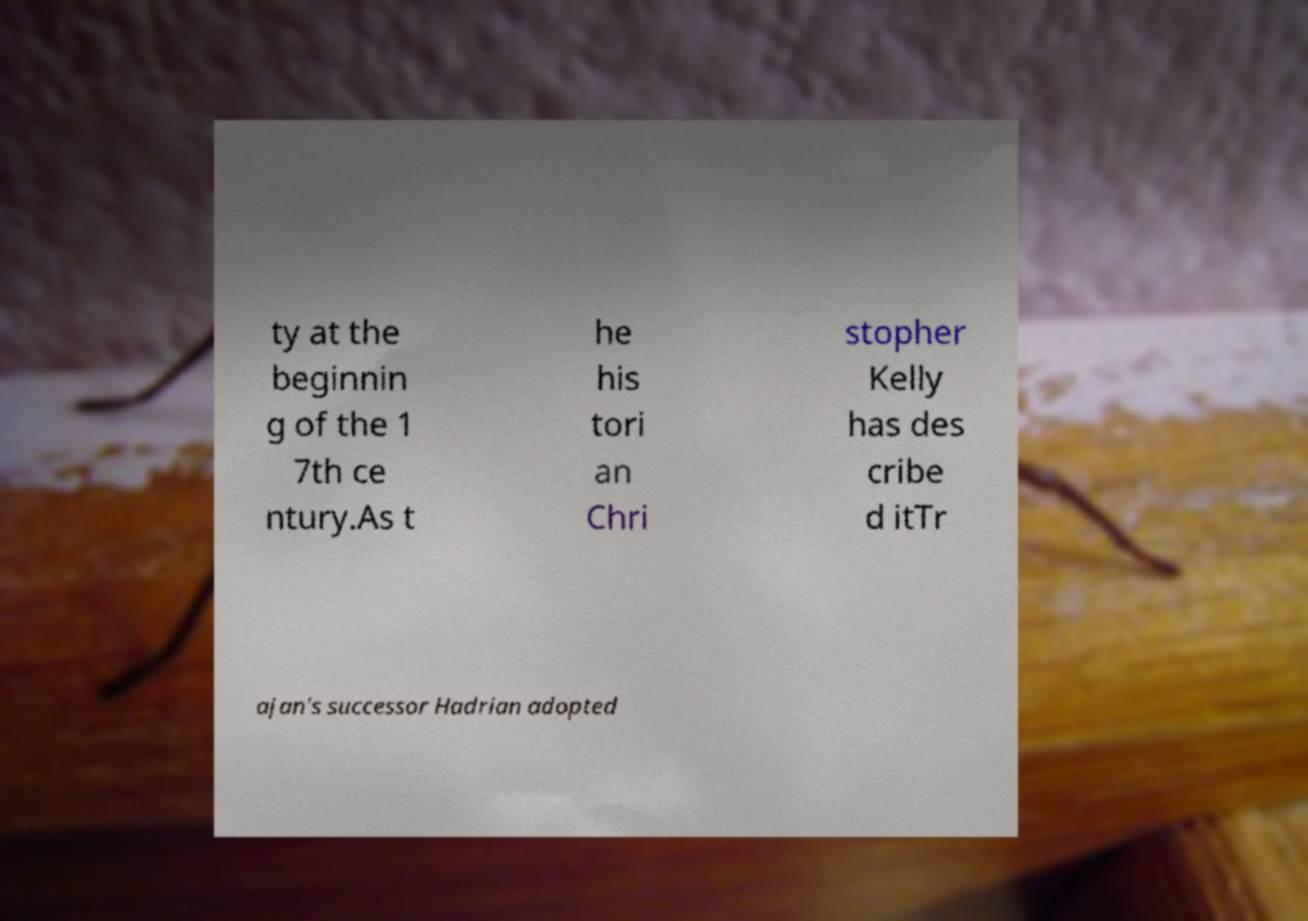What messages or text are displayed in this image? I need them in a readable, typed format. ty at the beginnin g of the 1 7th ce ntury.As t he his tori an Chri stopher Kelly has des cribe d itTr ajan's successor Hadrian adopted 